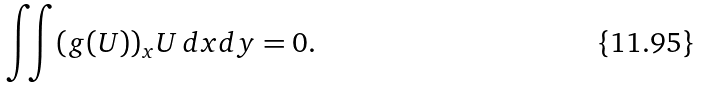Convert formula to latex. <formula><loc_0><loc_0><loc_500><loc_500>\iint ( g ( U ) ) _ { x } U \, d x d y = 0 .</formula> 